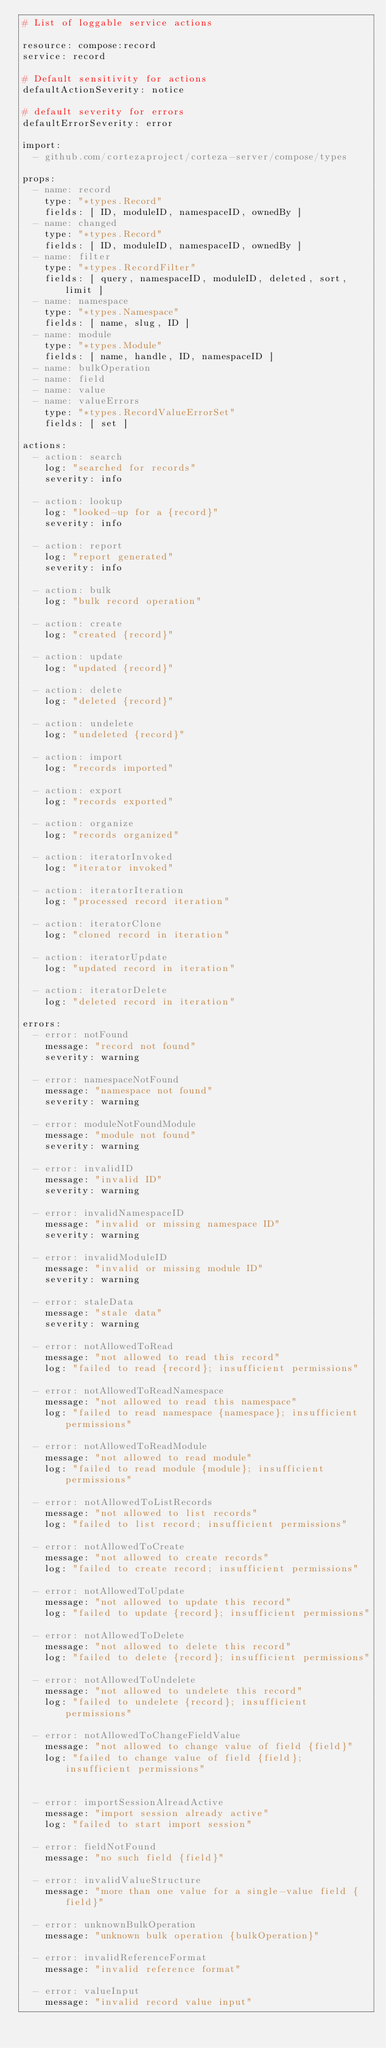Convert code to text. <code><loc_0><loc_0><loc_500><loc_500><_YAML_># List of loggable service actions

resource: compose:record
service: record

# Default sensitivity for actions
defaultActionSeverity: notice

# default severity for errors
defaultErrorSeverity: error

import:
  - github.com/cortezaproject/corteza-server/compose/types

props:
  - name: record
    type: "*types.Record"
    fields: [ ID, moduleID, namespaceID, ownedBy ]
  - name: changed
    type: "*types.Record"
    fields: [ ID, moduleID, namespaceID, ownedBy ]
  - name: filter
    type: "*types.RecordFilter"
    fields: [ query, namespaceID, moduleID, deleted, sort, limit ]
  - name: namespace
    type: "*types.Namespace"
    fields: [ name, slug, ID ]
  - name: module
    type: "*types.Module"
    fields: [ name, handle, ID, namespaceID ]
  - name: bulkOperation
  - name: field
  - name: value
  - name: valueErrors
    type: "*types.RecordValueErrorSet"
    fields: [ set ]

actions:
  - action: search
    log: "searched for records"
    severity: info

  - action: lookup
    log: "looked-up for a {record}"
    severity: info

  - action: report
    log: "report generated"
    severity: info

  - action: bulk
    log: "bulk record operation"

  - action: create
    log: "created {record}"

  - action: update
    log: "updated {record}"

  - action: delete
    log: "deleted {record}"

  - action: undelete
    log: "undeleted {record}"

  - action: import
    log: "records imported"

  - action: export
    log: "records exported"

  - action: organize
    log: "records organized"

  - action: iteratorInvoked
    log: "iterator invoked"

  - action: iteratorIteration
    log: "processed record iteration"

  - action: iteratorClone
    log: "cloned record in iteration"

  - action: iteratorUpdate
    log: "updated record in iteration"

  - action: iteratorDelete
    log: "deleted record in iteration"

errors:
  - error: notFound
    message: "record not found"
    severity: warning

  - error: namespaceNotFound
    message: "namespace not found"
    severity: warning

  - error: moduleNotFoundModule
    message: "module not found"
    severity: warning

  - error: invalidID
    message: "invalid ID"
    severity: warning

  - error: invalidNamespaceID
    message: "invalid or missing namespace ID"
    severity: warning

  - error: invalidModuleID
    message: "invalid or missing module ID"
    severity: warning

  - error: staleData
    message: "stale data"
    severity: warning

  - error: notAllowedToRead
    message: "not allowed to read this record"
    log: "failed to read {record}; insufficient permissions"

  - error: notAllowedToReadNamespace
    message: "not allowed to read this namespace"
    log: "failed to read namespace {namespace}; insufficient permissions"

  - error: notAllowedToReadModule
    message: "not allowed to read module"
    log: "failed to read module {module}; insufficient permissions"

  - error: notAllowedToListRecords
    message: "not allowed to list records"
    log: "failed to list record; insufficient permissions"

  - error: notAllowedToCreate
    message: "not allowed to create records"
    log: "failed to create record; insufficient permissions"

  - error: notAllowedToUpdate
    message: "not allowed to update this record"
    log: "failed to update {record}; insufficient permissions"

  - error: notAllowedToDelete
    message: "not allowed to delete this record"
    log: "failed to delete {record}; insufficient permissions"

  - error: notAllowedToUndelete
    message: "not allowed to undelete this record"
    log: "failed to undelete {record}; insufficient permissions"

  - error: notAllowedToChangeFieldValue
    message: "not allowed to change value of field {field}"
    log: "failed to change value of field {field}; insufficient permissions"


  - error: importSessionAlreadActive
    message: "import session already active"
    log: "failed to start import session"

  - error: fieldNotFound
    message: "no such field {field}"

  - error: invalidValueStructure
    message: "more than one value for a single-value field {field}"

  - error: unknownBulkOperation
    message: "unknown bulk operation {bulkOperation}"

  - error: invalidReferenceFormat
    message: "invalid reference format"

  - error: valueInput
    message: "invalid record value input"
</code> 